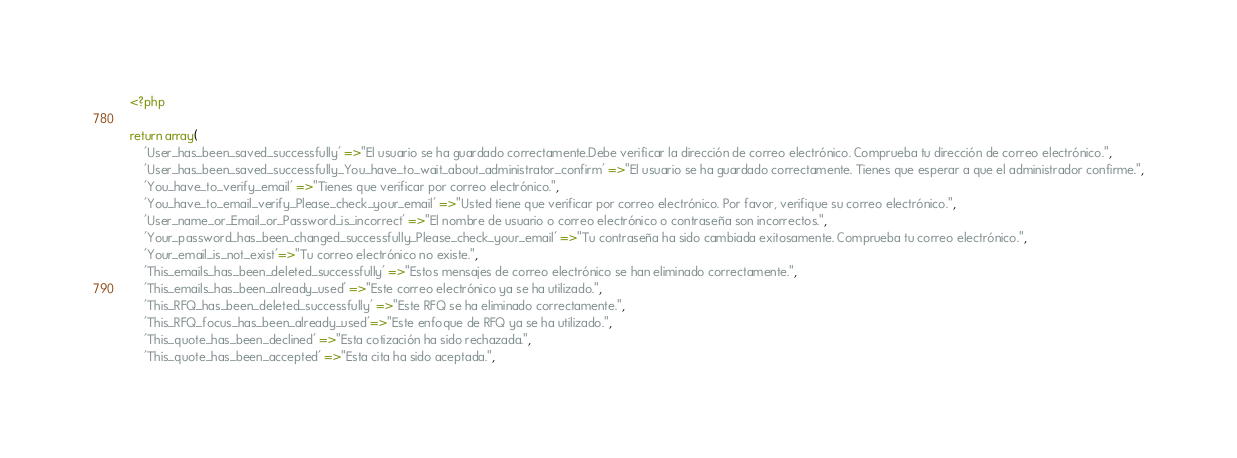<code> <loc_0><loc_0><loc_500><loc_500><_PHP_><?php

return array(
    'User_has_been_saved_successfully' =>"El usuario se ha guardado correctamente.Debe verificar la dirección de correo electrónico. Comprueba tu dirección de correo electrónico.",
    'User_has_been_saved_successfully_You_have_to_wait_about_administrator_confirm' =>"El usuario se ha guardado correctamente. Tienes que esperar a que el administrador confirme.",
    'You_have_to_verify_email' =>"Tienes que verificar por correo electrónico.",
    'You_have_to_email_verify_Please_check_your_email' =>"Usted tiene que verificar por correo electrónico. Por favor, verifique su correo electrónico.",
    'User_name_or_Email_or_Password_is_incorrect' =>"El nombre de usuario o correo electrónico o contraseña son incorrectos.",
    'Your_password_has_been_changed_successfully_Please_check_your_email' =>"Tu contraseña ha sido cambiada exitosamente. Comprueba tu correo electrónico.",
    'Your_email_is_not_exist'=>"Tu correo electrónico no existe.",
    'This_emails_has_been_deleted_successfully' =>"Estos mensajes de correo electrónico se han eliminado correctamente.",
    'This_emails_has_been_already_used' =>"Este correo electrónico ya se ha utilizado.",
    'This_RFQ_has_been_deleted_successfully' =>"Este RFQ se ha eliminado correctamente.",
    'This_RFQ_focus_has_been_already_used'=>"Este enfoque de RFQ ya se ha utilizado.",
    'This_quote_has_been_declined' =>"Esta cotización ha sido rechazada.",
    'This_quote_has_been_accepted' =>"Esta cita ha sido aceptada.",</code> 